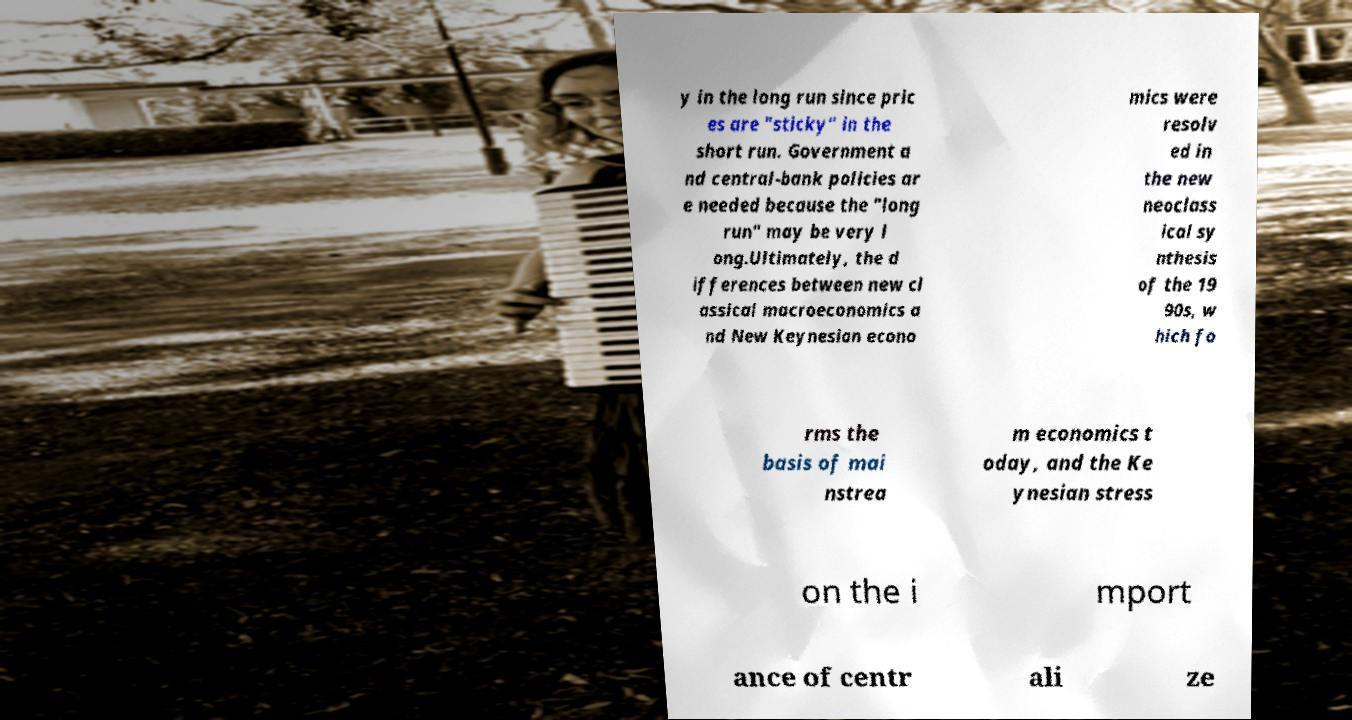Please read and relay the text visible in this image. What does it say? y in the long run since pric es are "sticky" in the short run. Government a nd central-bank policies ar e needed because the "long run" may be very l ong.Ultimately, the d ifferences between new cl assical macroeconomics a nd New Keynesian econo mics were resolv ed in the new neoclass ical sy nthesis of the 19 90s, w hich fo rms the basis of mai nstrea m economics t oday, and the Ke ynesian stress on the i mport ance of centr ali ze 